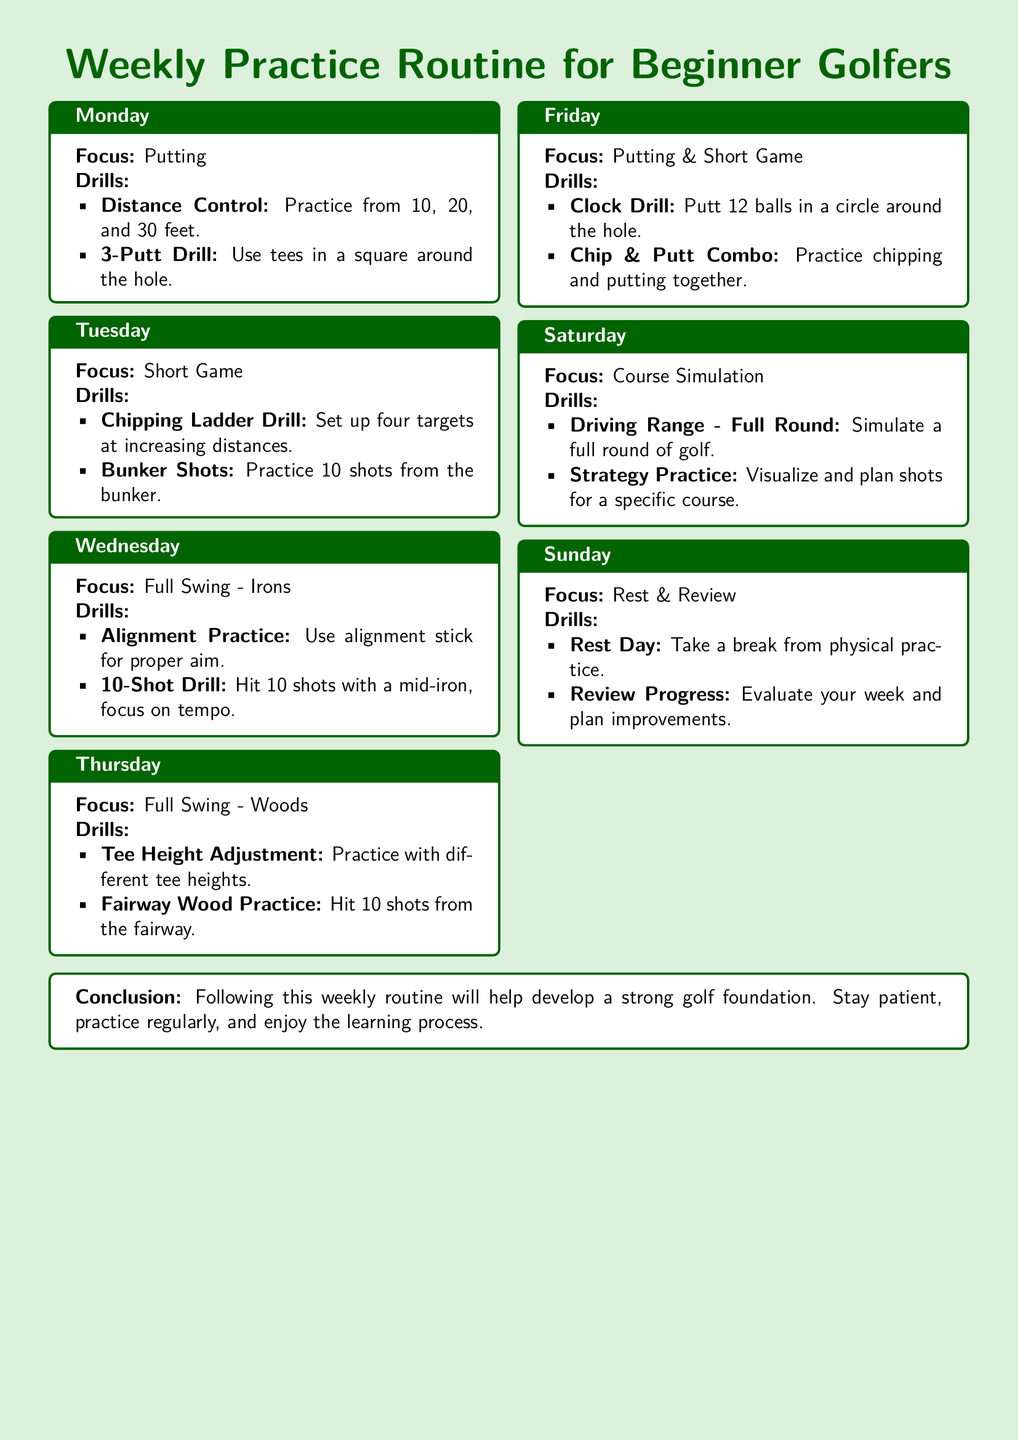What is the focus for Monday's practice? The document states that the focus for Monday's practice is putting.
Answer: Putting How many shots should be practiced from the bunker on Tuesday? The document specifies that 10 shots should be practiced from the bunker on Tuesday.
Answer: 10 What drill is used for distance control in putting? The document mentions practicing from distances of 10, 20, and 30 feet for distance control.
Answer: Distance Control What is the title of the document? The title of the document is provided at the beginning, which is "Weekly Practice Routine for Beginner Golfers."
Answer: Weekly Practice Routine for Beginner Golfers What should be evaluated on Sunday? The document states that progress should be reviewed on Sunday.
Answer: Progress Which day’s practice involves Fairway Wood Practice? The day designated for Fairway Wood Practice is Thursday.
Answer: Thursday What does the Clock Drill involve? The Clock Drill involves putting 12 balls in a circle around the hole.
Answer: 12 balls How many drills focus on putting and short game on Friday? The document lists two drills that focus on putting and short game on Friday.
Answer: Two What is the focus of practice on Wednesday? The focus of practice on Wednesday is Full Swing - Irons.
Answer: Full Swing - Irons 